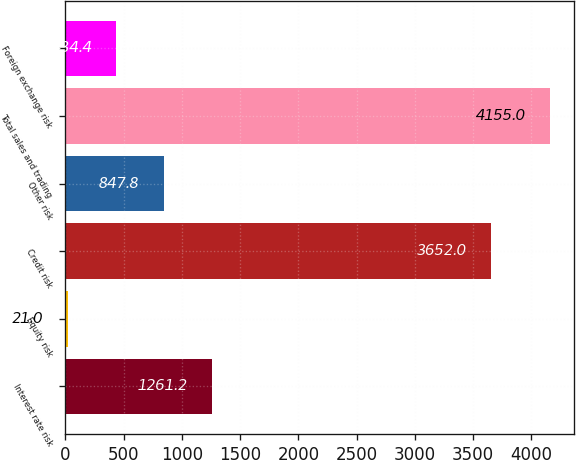Convert chart to OTSL. <chart><loc_0><loc_0><loc_500><loc_500><bar_chart><fcel>Interest rate risk<fcel>Equity risk<fcel>Credit risk<fcel>Other risk<fcel>Total sales and trading<fcel>Foreign exchange risk<nl><fcel>1261.2<fcel>21<fcel>3652<fcel>847.8<fcel>4155<fcel>434.4<nl></chart> 